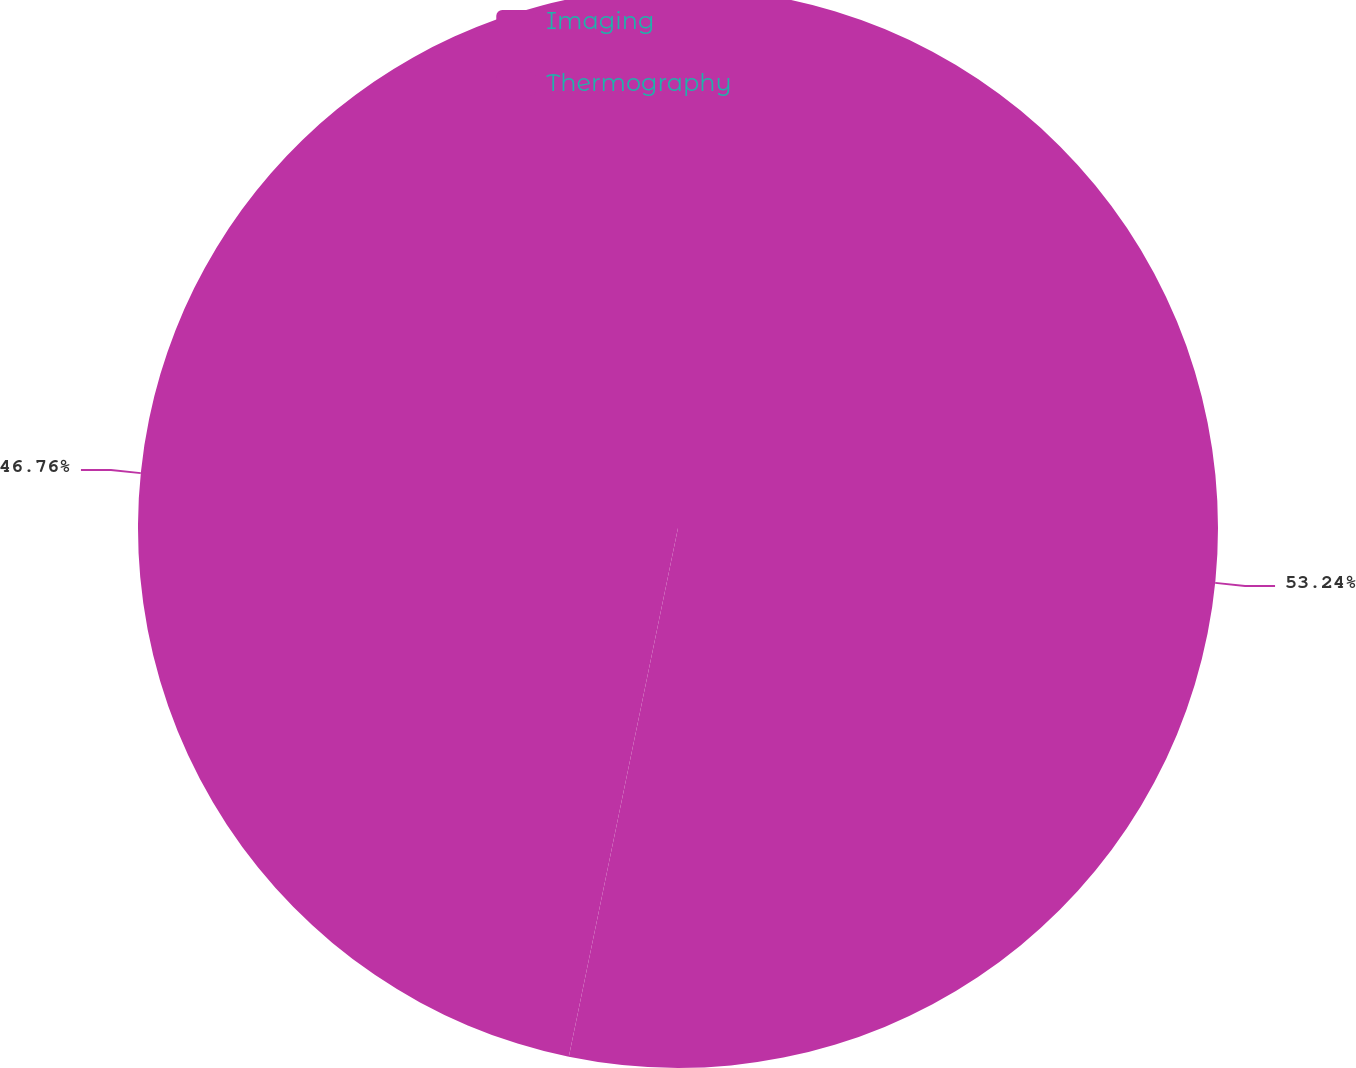Convert chart. <chart><loc_0><loc_0><loc_500><loc_500><pie_chart><fcel>Imaging<fcel>Thermography<nl><fcel>53.24%<fcel>46.76%<nl></chart> 